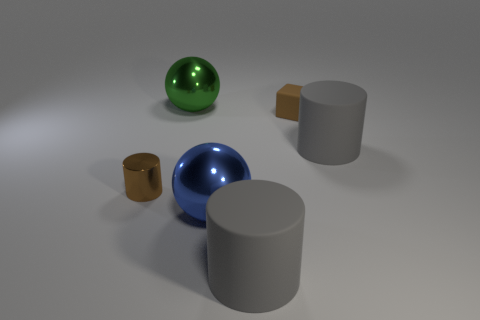There is a matte cylinder that is in front of the large blue metal sphere; are there any small brown matte blocks to the left of it?
Your answer should be very brief. No. What color is the other big object that is the same shape as the blue thing?
Keep it short and to the point. Green. Are there any other things that are the same shape as the green thing?
Provide a short and direct response. Yes. There is a tiny thing that is made of the same material as the large green thing; what is its color?
Make the answer very short. Brown. Are there any matte cubes on the right side of the gray matte cylinder behind the shiny thing right of the green thing?
Your answer should be compact. No. Are there fewer tiny brown things to the left of the small cylinder than big shiny things to the right of the small rubber thing?
Provide a short and direct response. No. How many tiny gray cylinders have the same material as the large blue ball?
Offer a terse response. 0. Does the blue metallic object have the same size as the gray cylinder in front of the small brown cylinder?
Give a very brief answer. Yes. What material is the cube that is the same color as the small metallic cylinder?
Your answer should be compact. Rubber. What is the size of the cylinder that is to the left of the ball that is behind the blue ball that is in front of the cube?
Offer a terse response. Small. 